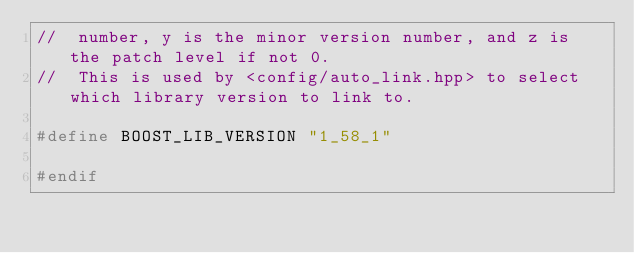<code> <loc_0><loc_0><loc_500><loc_500><_C++_>//  number, y is the minor version number, and z is the patch level if not 0.
//  This is used by <config/auto_link.hpp> to select which library version to link to.

#define BOOST_LIB_VERSION "1_58_1"

#endif
</code> 